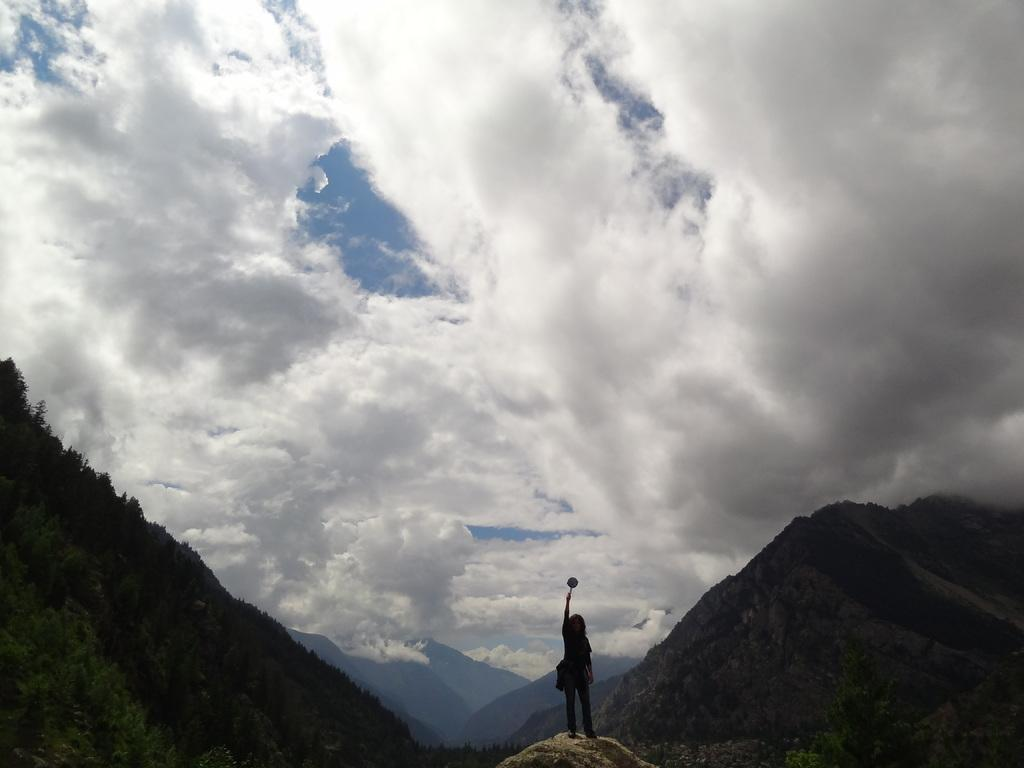What is the main subject of the image? There is a person standing in the image. What is the person holding in their hand? The person is holding an object in their hand. What type of natural environment can be seen in the image? There are trees and mountains visible in the image. How would you describe the weather in the image? The sky is cloudy in the image. What type of tent can be seen in the image? There is no tent present in the image. How many times has the person folded the object in their hand? The image does not provide information about the object being folded or the number of times it has been folded. 